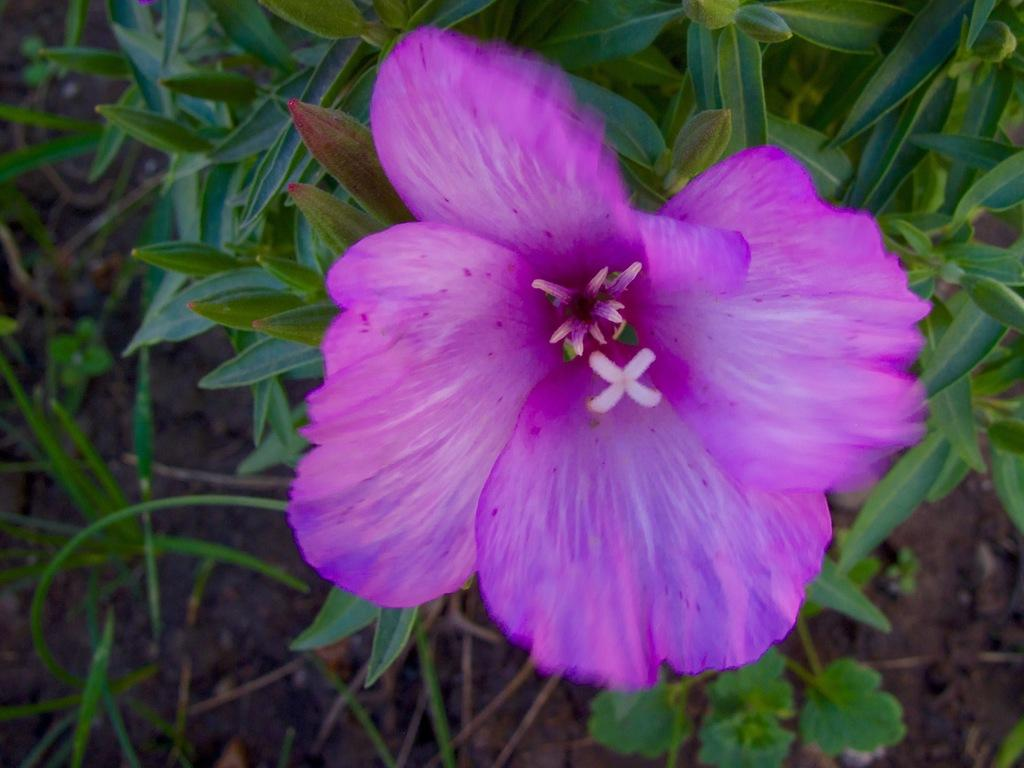What type of flower is in the image? There is a purple color flower in the image. What else can be seen in the image besides the flower? There are leaves in the image. How many petals does the flower have? The flower has petals. How does the flower react to the pest in the image? There is no pest present in the image, so the flower's reaction cannot be determined. 